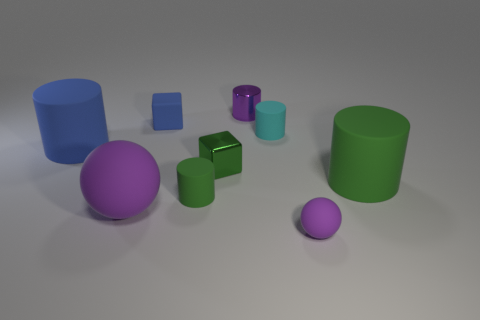Are there any things of the same color as the metal cylinder?
Your response must be concise. Yes. How many big objects are either cylinders or red rubber cylinders?
Offer a terse response. 2. What number of large green matte objects are there?
Your answer should be compact. 1. What material is the small cube that is in front of the tiny cyan rubber cylinder?
Give a very brief answer. Metal. There is a tiny sphere; are there any cylinders on the right side of it?
Keep it short and to the point. Yes. Is the size of the purple metallic object the same as the blue cylinder?
Keep it short and to the point. No. What number of large objects are the same material as the purple cylinder?
Keep it short and to the point. 0. There is a matte object that is right of the small purple sphere that is on the right side of the tiny cyan cylinder; what is its size?
Ensure brevity in your answer.  Large. There is a matte cylinder that is both to the right of the big purple sphere and behind the large green matte thing; what color is it?
Provide a short and direct response. Cyan. Is the tiny blue thing the same shape as the green metallic thing?
Your answer should be very brief. Yes. 